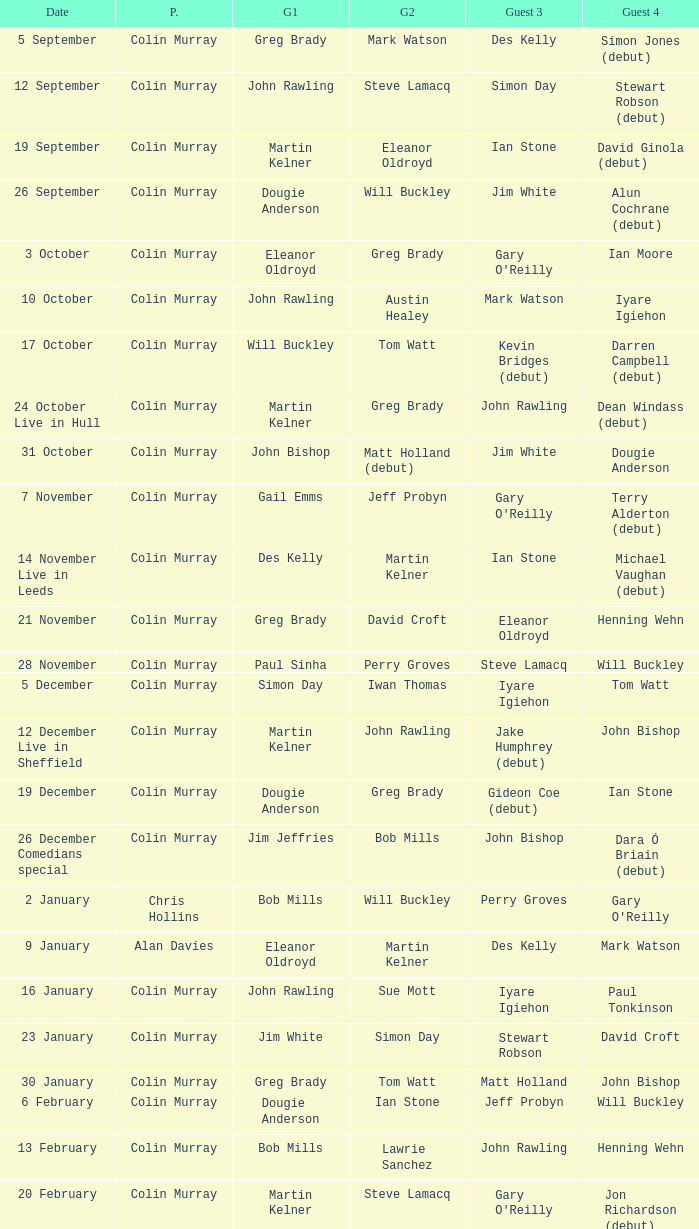On episodes where guest 1 is Jim White, who was guest 3? Stewart Robson. 